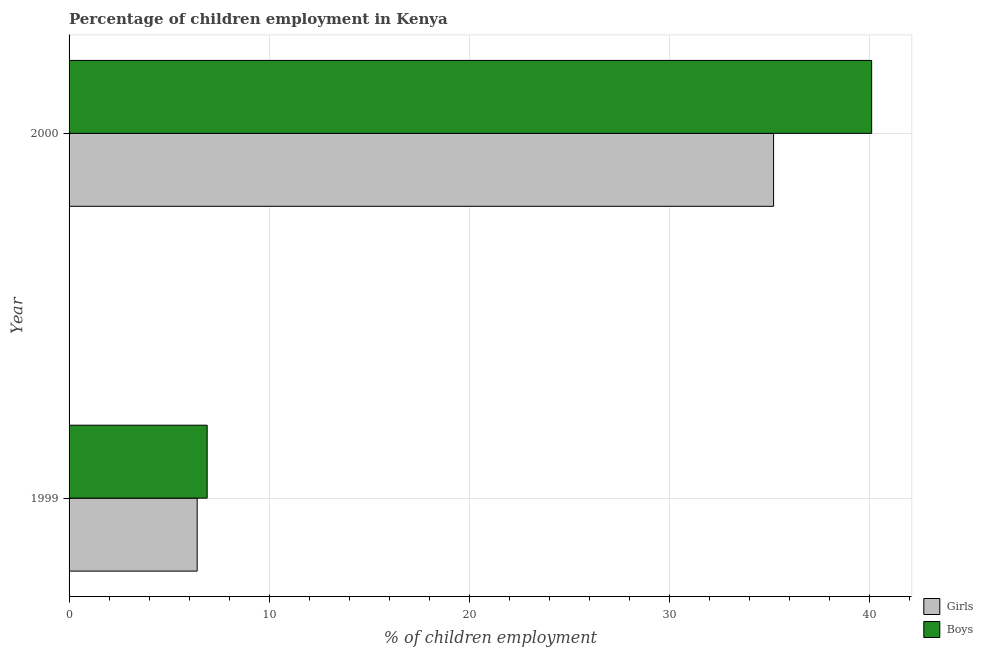Are the number of bars per tick equal to the number of legend labels?
Make the answer very short. Yes. Are the number of bars on each tick of the Y-axis equal?
Offer a terse response. Yes. How many bars are there on the 1st tick from the top?
Provide a short and direct response. 2. What is the percentage of employed boys in 1999?
Your answer should be very brief. 6.9. Across all years, what is the maximum percentage of employed girls?
Offer a terse response. 35.2. In which year was the percentage of employed boys maximum?
Your response must be concise. 2000. In which year was the percentage of employed boys minimum?
Provide a succinct answer. 1999. What is the total percentage of employed boys in the graph?
Keep it short and to the point. 47. What is the difference between the percentage of employed boys in 1999 and that in 2000?
Keep it short and to the point. -33.2. What is the difference between the percentage of employed boys in 2000 and the percentage of employed girls in 1999?
Offer a terse response. 33.7. What is the average percentage of employed girls per year?
Provide a succinct answer. 20.8. In how many years, is the percentage of employed boys greater than 12 %?
Your answer should be very brief. 1. What is the ratio of the percentage of employed boys in 1999 to that in 2000?
Offer a terse response. 0.17. Is the difference between the percentage of employed girls in 1999 and 2000 greater than the difference between the percentage of employed boys in 1999 and 2000?
Give a very brief answer. Yes. What does the 1st bar from the top in 2000 represents?
Give a very brief answer. Boys. What does the 1st bar from the bottom in 1999 represents?
Make the answer very short. Girls. How many bars are there?
Make the answer very short. 4. How many years are there in the graph?
Ensure brevity in your answer.  2. What is the difference between two consecutive major ticks on the X-axis?
Provide a succinct answer. 10. Does the graph contain grids?
Offer a terse response. Yes. How many legend labels are there?
Ensure brevity in your answer.  2. What is the title of the graph?
Keep it short and to the point. Percentage of children employment in Kenya. Does "Electricity and heat production" appear as one of the legend labels in the graph?
Give a very brief answer. No. What is the label or title of the X-axis?
Give a very brief answer. % of children employment. What is the % of children employment in Girls in 1999?
Give a very brief answer. 6.4. What is the % of children employment in Girls in 2000?
Offer a terse response. 35.2. What is the % of children employment in Boys in 2000?
Make the answer very short. 40.1. Across all years, what is the maximum % of children employment in Girls?
Give a very brief answer. 35.2. Across all years, what is the maximum % of children employment in Boys?
Your answer should be compact. 40.1. Across all years, what is the minimum % of children employment in Boys?
Keep it short and to the point. 6.9. What is the total % of children employment in Girls in the graph?
Offer a very short reply. 41.6. What is the difference between the % of children employment of Girls in 1999 and that in 2000?
Offer a terse response. -28.8. What is the difference between the % of children employment in Boys in 1999 and that in 2000?
Ensure brevity in your answer.  -33.2. What is the difference between the % of children employment in Girls in 1999 and the % of children employment in Boys in 2000?
Provide a short and direct response. -33.7. What is the average % of children employment of Girls per year?
Your answer should be very brief. 20.8. What is the average % of children employment of Boys per year?
Your response must be concise. 23.5. In the year 1999, what is the difference between the % of children employment of Girls and % of children employment of Boys?
Provide a succinct answer. -0.5. In the year 2000, what is the difference between the % of children employment of Girls and % of children employment of Boys?
Your answer should be compact. -4.9. What is the ratio of the % of children employment of Girls in 1999 to that in 2000?
Provide a succinct answer. 0.18. What is the ratio of the % of children employment of Boys in 1999 to that in 2000?
Keep it short and to the point. 0.17. What is the difference between the highest and the second highest % of children employment in Girls?
Give a very brief answer. 28.8. What is the difference between the highest and the second highest % of children employment in Boys?
Your answer should be very brief. 33.2. What is the difference between the highest and the lowest % of children employment in Girls?
Make the answer very short. 28.8. What is the difference between the highest and the lowest % of children employment in Boys?
Provide a short and direct response. 33.2. 